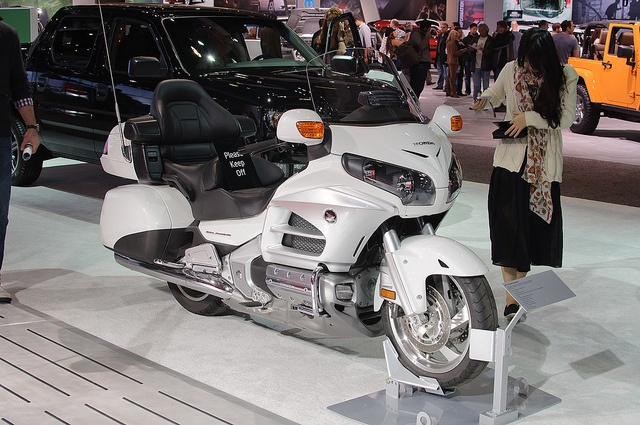Describe the objects in this image and their specific colors. I can see motorcycle in gray, black, lightgray, and darkgray tones, truck in gray, black, darkgray, and navy tones, people in gray, black, and darkgray tones, truck in gray, orange, black, and red tones, and people in gray, black, maroon, and darkgray tones in this image. 